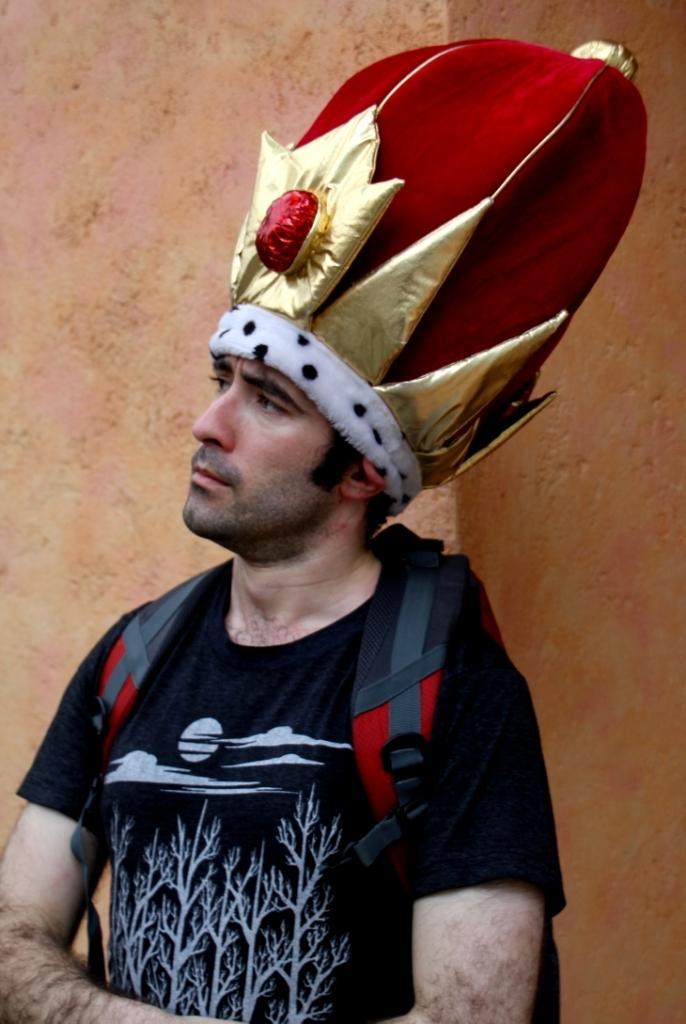Please provide a concise description of this image. This picture shows a man standing and he wore a backpack on his back and a cap on his head and we see a wall on the back and he wore a black color t-shirt. 